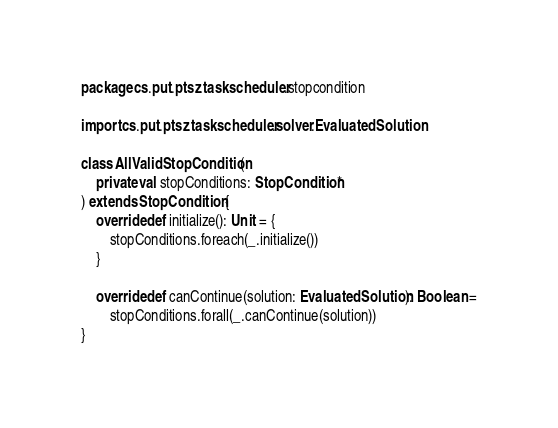<code> <loc_0><loc_0><loc_500><loc_500><_Scala_>package cs.put.ptsz.taskscheduler.stopcondition

import cs.put.ptsz.taskscheduler.solver.EvaluatedSolution

class AllValidStopCondition(
	private val stopConditions: StopCondition*
) extends StopCondition {
	override def initialize(): Unit = {
		stopConditions.foreach(_.initialize())
	}

	override def canContinue(solution: EvaluatedSolution): Boolean =
		stopConditions.forall(_.canContinue(solution))
}
</code> 